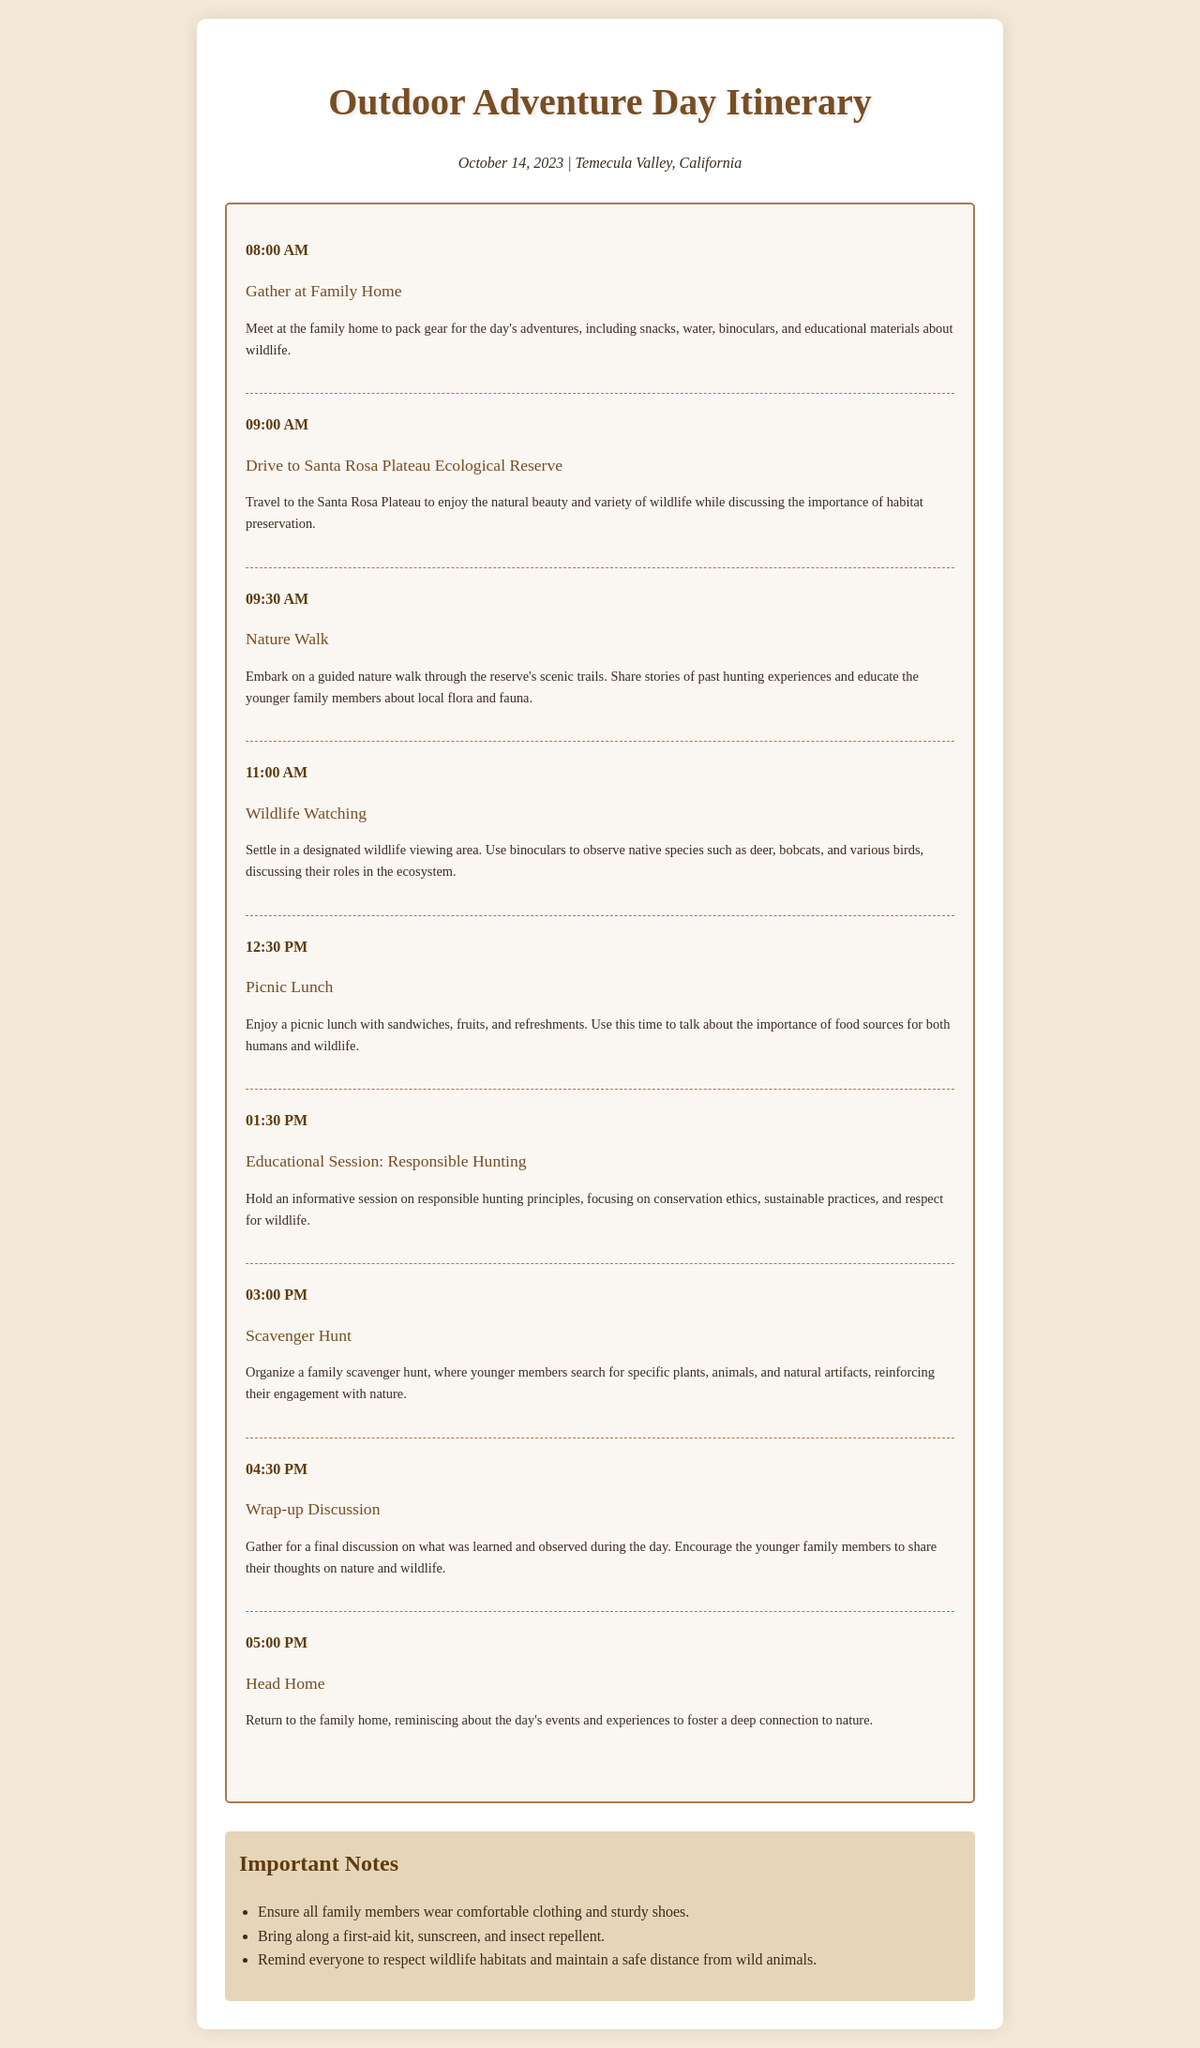What time does the picnic lunch start? The schedule outlines the time for the picnic lunch as noted in the corresponding schedule item.
Answer: 12:30 PM What activity is scheduled after wildlife watching? The document lists the activities in chronological order, showing what follows the wildlife watching.
Answer: Picnic Lunch How many activities are planned for the day? The total number of schedule items listed gives insight into the number of activities planned.
Answer: 8 activities What is the last activity of the day? The final schedule item describes the last activity before heading home.
Answer: Head Home What is the focus of the educational session? The description under the specific time for the educational session details its main topic.
Answer: Responsible Hunting Where are family members gathering initially? The first schedule item describes the initial meeting point for the family.
Answer: Family Home What should family members wear for the outing? The notes section indicates attire suitability for the day’s activities.
Answer: Comfortable clothing and sturdy shoes What type of reserve will the family visit? The title of the destination in the transportation activity points to the specific area of interest.
Answer: Santa Rosa Plateau Ecological Reserve 